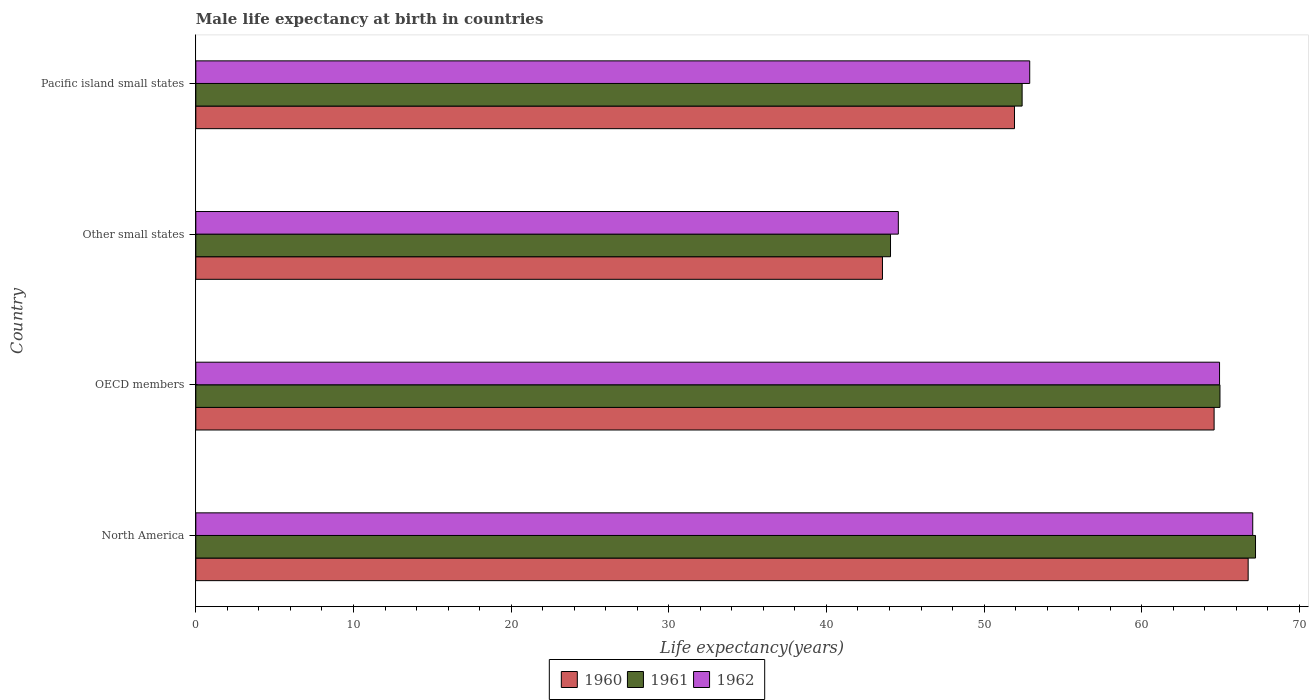How many different coloured bars are there?
Your answer should be compact. 3. How many groups of bars are there?
Your answer should be compact. 4. How many bars are there on the 3rd tick from the bottom?
Your answer should be compact. 3. What is the label of the 2nd group of bars from the top?
Ensure brevity in your answer.  Other small states. In how many cases, is the number of bars for a given country not equal to the number of legend labels?
Offer a very short reply. 0. What is the male life expectancy at birth in 1962 in Other small states?
Provide a succinct answer. 44.56. Across all countries, what is the maximum male life expectancy at birth in 1962?
Offer a terse response. 67.04. Across all countries, what is the minimum male life expectancy at birth in 1962?
Provide a short and direct response. 44.56. In which country was the male life expectancy at birth in 1960 maximum?
Give a very brief answer. North America. In which country was the male life expectancy at birth in 1960 minimum?
Provide a short and direct response. Other small states. What is the total male life expectancy at birth in 1960 in the graph?
Offer a terse response. 226.83. What is the difference between the male life expectancy at birth in 1960 in OECD members and that in Other small states?
Give a very brief answer. 21.04. What is the difference between the male life expectancy at birth in 1960 in North America and the male life expectancy at birth in 1962 in Other small states?
Give a very brief answer. 22.19. What is the average male life expectancy at birth in 1961 per country?
Provide a succinct answer. 57.17. What is the difference between the male life expectancy at birth in 1960 and male life expectancy at birth in 1962 in OECD members?
Offer a terse response. -0.34. In how many countries, is the male life expectancy at birth in 1960 greater than 46 years?
Make the answer very short. 3. What is the ratio of the male life expectancy at birth in 1961 in Other small states to that in Pacific island small states?
Provide a short and direct response. 0.84. Is the male life expectancy at birth in 1962 in North America less than that in Pacific island small states?
Provide a succinct answer. No. Is the difference between the male life expectancy at birth in 1960 in North America and Other small states greater than the difference between the male life expectancy at birth in 1962 in North America and Other small states?
Your answer should be very brief. Yes. What is the difference between the highest and the second highest male life expectancy at birth in 1961?
Keep it short and to the point. 2.25. What is the difference between the highest and the lowest male life expectancy at birth in 1962?
Ensure brevity in your answer.  22.48. Is the sum of the male life expectancy at birth in 1961 in OECD members and Other small states greater than the maximum male life expectancy at birth in 1962 across all countries?
Give a very brief answer. Yes. What does the 3rd bar from the bottom in Other small states represents?
Keep it short and to the point. 1962. How many countries are there in the graph?
Keep it short and to the point. 4. What is the difference between two consecutive major ticks on the X-axis?
Provide a short and direct response. 10. How many legend labels are there?
Ensure brevity in your answer.  3. How are the legend labels stacked?
Your answer should be very brief. Horizontal. What is the title of the graph?
Keep it short and to the point. Male life expectancy at birth in countries. What is the label or title of the X-axis?
Make the answer very short. Life expectancy(years). What is the Life expectancy(years) in 1960 in North America?
Your answer should be very brief. 66.75. What is the Life expectancy(years) in 1961 in North America?
Your answer should be very brief. 67.22. What is the Life expectancy(years) in 1962 in North America?
Provide a short and direct response. 67.04. What is the Life expectancy(years) of 1960 in OECD members?
Offer a very short reply. 64.59. What is the Life expectancy(years) of 1961 in OECD members?
Offer a very short reply. 64.96. What is the Life expectancy(years) in 1962 in OECD members?
Provide a short and direct response. 64.94. What is the Life expectancy(years) in 1960 in Other small states?
Your answer should be compact. 43.56. What is the Life expectancy(years) in 1961 in Other small states?
Offer a very short reply. 44.07. What is the Life expectancy(years) in 1962 in Other small states?
Your answer should be compact. 44.56. What is the Life expectancy(years) in 1960 in Pacific island small states?
Make the answer very short. 51.93. What is the Life expectancy(years) of 1961 in Pacific island small states?
Make the answer very short. 52.41. What is the Life expectancy(years) in 1962 in Pacific island small states?
Offer a very short reply. 52.9. Across all countries, what is the maximum Life expectancy(years) in 1960?
Offer a very short reply. 66.75. Across all countries, what is the maximum Life expectancy(years) of 1961?
Provide a succinct answer. 67.22. Across all countries, what is the maximum Life expectancy(years) of 1962?
Make the answer very short. 67.04. Across all countries, what is the minimum Life expectancy(years) in 1960?
Offer a terse response. 43.56. Across all countries, what is the minimum Life expectancy(years) in 1961?
Your response must be concise. 44.07. Across all countries, what is the minimum Life expectancy(years) in 1962?
Make the answer very short. 44.56. What is the total Life expectancy(years) in 1960 in the graph?
Keep it short and to the point. 226.83. What is the total Life expectancy(years) of 1961 in the graph?
Provide a succinct answer. 228.66. What is the total Life expectancy(years) in 1962 in the graph?
Give a very brief answer. 229.44. What is the difference between the Life expectancy(years) in 1960 in North America and that in OECD members?
Make the answer very short. 2.16. What is the difference between the Life expectancy(years) in 1961 in North America and that in OECD members?
Offer a very short reply. 2.25. What is the difference between the Life expectancy(years) of 1962 in North America and that in OECD members?
Give a very brief answer. 2.11. What is the difference between the Life expectancy(years) of 1960 in North America and that in Other small states?
Your response must be concise. 23.2. What is the difference between the Life expectancy(years) in 1961 in North America and that in Other small states?
Your answer should be compact. 23.15. What is the difference between the Life expectancy(years) in 1962 in North America and that in Other small states?
Your answer should be compact. 22.48. What is the difference between the Life expectancy(years) in 1960 in North America and that in Pacific island small states?
Provide a short and direct response. 14.82. What is the difference between the Life expectancy(years) of 1961 in North America and that in Pacific island small states?
Make the answer very short. 14.8. What is the difference between the Life expectancy(years) in 1962 in North America and that in Pacific island small states?
Offer a terse response. 14.15. What is the difference between the Life expectancy(years) in 1960 in OECD members and that in Other small states?
Offer a terse response. 21.04. What is the difference between the Life expectancy(years) of 1961 in OECD members and that in Other small states?
Offer a terse response. 20.9. What is the difference between the Life expectancy(years) of 1962 in OECD members and that in Other small states?
Ensure brevity in your answer.  20.38. What is the difference between the Life expectancy(years) in 1960 in OECD members and that in Pacific island small states?
Make the answer very short. 12.66. What is the difference between the Life expectancy(years) of 1961 in OECD members and that in Pacific island small states?
Make the answer very short. 12.55. What is the difference between the Life expectancy(years) of 1962 in OECD members and that in Pacific island small states?
Offer a very short reply. 12.04. What is the difference between the Life expectancy(years) of 1960 in Other small states and that in Pacific island small states?
Provide a succinct answer. -8.37. What is the difference between the Life expectancy(years) in 1961 in Other small states and that in Pacific island small states?
Provide a succinct answer. -8.35. What is the difference between the Life expectancy(years) in 1962 in Other small states and that in Pacific island small states?
Your answer should be very brief. -8.33. What is the difference between the Life expectancy(years) of 1960 in North America and the Life expectancy(years) of 1961 in OECD members?
Ensure brevity in your answer.  1.79. What is the difference between the Life expectancy(years) of 1960 in North America and the Life expectancy(years) of 1962 in OECD members?
Make the answer very short. 1.82. What is the difference between the Life expectancy(years) of 1961 in North America and the Life expectancy(years) of 1962 in OECD members?
Offer a terse response. 2.28. What is the difference between the Life expectancy(years) of 1960 in North America and the Life expectancy(years) of 1961 in Other small states?
Make the answer very short. 22.69. What is the difference between the Life expectancy(years) in 1960 in North America and the Life expectancy(years) in 1962 in Other small states?
Make the answer very short. 22.19. What is the difference between the Life expectancy(years) in 1961 in North America and the Life expectancy(years) in 1962 in Other small states?
Provide a succinct answer. 22.66. What is the difference between the Life expectancy(years) in 1960 in North America and the Life expectancy(years) in 1961 in Pacific island small states?
Offer a very short reply. 14.34. What is the difference between the Life expectancy(years) of 1960 in North America and the Life expectancy(years) of 1962 in Pacific island small states?
Offer a very short reply. 13.86. What is the difference between the Life expectancy(years) of 1961 in North America and the Life expectancy(years) of 1962 in Pacific island small states?
Your answer should be compact. 14.32. What is the difference between the Life expectancy(years) in 1960 in OECD members and the Life expectancy(years) in 1961 in Other small states?
Your response must be concise. 20.53. What is the difference between the Life expectancy(years) of 1960 in OECD members and the Life expectancy(years) of 1962 in Other small states?
Your answer should be compact. 20.03. What is the difference between the Life expectancy(years) of 1961 in OECD members and the Life expectancy(years) of 1962 in Other small states?
Give a very brief answer. 20.4. What is the difference between the Life expectancy(years) in 1960 in OECD members and the Life expectancy(years) in 1961 in Pacific island small states?
Provide a succinct answer. 12.18. What is the difference between the Life expectancy(years) in 1960 in OECD members and the Life expectancy(years) in 1962 in Pacific island small states?
Keep it short and to the point. 11.7. What is the difference between the Life expectancy(years) of 1961 in OECD members and the Life expectancy(years) of 1962 in Pacific island small states?
Offer a very short reply. 12.07. What is the difference between the Life expectancy(years) in 1960 in Other small states and the Life expectancy(years) in 1961 in Pacific island small states?
Your response must be concise. -8.86. What is the difference between the Life expectancy(years) of 1960 in Other small states and the Life expectancy(years) of 1962 in Pacific island small states?
Your response must be concise. -9.34. What is the difference between the Life expectancy(years) in 1961 in Other small states and the Life expectancy(years) in 1962 in Pacific island small states?
Ensure brevity in your answer.  -8.83. What is the average Life expectancy(years) of 1960 per country?
Make the answer very short. 56.71. What is the average Life expectancy(years) of 1961 per country?
Provide a succinct answer. 57.17. What is the average Life expectancy(years) of 1962 per country?
Keep it short and to the point. 57.36. What is the difference between the Life expectancy(years) in 1960 and Life expectancy(years) in 1961 in North America?
Keep it short and to the point. -0.47. What is the difference between the Life expectancy(years) of 1960 and Life expectancy(years) of 1962 in North America?
Offer a terse response. -0.29. What is the difference between the Life expectancy(years) of 1961 and Life expectancy(years) of 1962 in North America?
Your answer should be very brief. 0.18. What is the difference between the Life expectancy(years) of 1960 and Life expectancy(years) of 1961 in OECD members?
Give a very brief answer. -0.37. What is the difference between the Life expectancy(years) of 1960 and Life expectancy(years) of 1962 in OECD members?
Offer a very short reply. -0.34. What is the difference between the Life expectancy(years) in 1961 and Life expectancy(years) in 1962 in OECD members?
Offer a very short reply. 0.03. What is the difference between the Life expectancy(years) of 1960 and Life expectancy(years) of 1961 in Other small states?
Provide a short and direct response. -0.51. What is the difference between the Life expectancy(years) of 1960 and Life expectancy(years) of 1962 in Other small states?
Offer a terse response. -1.01. What is the difference between the Life expectancy(years) of 1961 and Life expectancy(years) of 1962 in Other small states?
Make the answer very short. -0.5. What is the difference between the Life expectancy(years) in 1960 and Life expectancy(years) in 1961 in Pacific island small states?
Offer a very short reply. -0.49. What is the difference between the Life expectancy(years) in 1960 and Life expectancy(years) in 1962 in Pacific island small states?
Provide a succinct answer. -0.97. What is the difference between the Life expectancy(years) in 1961 and Life expectancy(years) in 1962 in Pacific island small states?
Give a very brief answer. -0.48. What is the ratio of the Life expectancy(years) in 1960 in North America to that in OECD members?
Provide a succinct answer. 1.03. What is the ratio of the Life expectancy(years) of 1961 in North America to that in OECD members?
Your answer should be very brief. 1.03. What is the ratio of the Life expectancy(years) in 1962 in North America to that in OECD members?
Your response must be concise. 1.03. What is the ratio of the Life expectancy(years) of 1960 in North America to that in Other small states?
Provide a short and direct response. 1.53. What is the ratio of the Life expectancy(years) of 1961 in North America to that in Other small states?
Provide a succinct answer. 1.53. What is the ratio of the Life expectancy(years) in 1962 in North America to that in Other small states?
Give a very brief answer. 1.5. What is the ratio of the Life expectancy(years) in 1960 in North America to that in Pacific island small states?
Keep it short and to the point. 1.29. What is the ratio of the Life expectancy(years) in 1961 in North America to that in Pacific island small states?
Make the answer very short. 1.28. What is the ratio of the Life expectancy(years) of 1962 in North America to that in Pacific island small states?
Your response must be concise. 1.27. What is the ratio of the Life expectancy(years) in 1960 in OECD members to that in Other small states?
Ensure brevity in your answer.  1.48. What is the ratio of the Life expectancy(years) of 1961 in OECD members to that in Other small states?
Provide a succinct answer. 1.47. What is the ratio of the Life expectancy(years) in 1962 in OECD members to that in Other small states?
Your response must be concise. 1.46. What is the ratio of the Life expectancy(years) of 1960 in OECD members to that in Pacific island small states?
Your answer should be compact. 1.24. What is the ratio of the Life expectancy(years) in 1961 in OECD members to that in Pacific island small states?
Keep it short and to the point. 1.24. What is the ratio of the Life expectancy(years) of 1962 in OECD members to that in Pacific island small states?
Make the answer very short. 1.23. What is the ratio of the Life expectancy(years) of 1960 in Other small states to that in Pacific island small states?
Ensure brevity in your answer.  0.84. What is the ratio of the Life expectancy(years) of 1961 in Other small states to that in Pacific island small states?
Your answer should be compact. 0.84. What is the ratio of the Life expectancy(years) of 1962 in Other small states to that in Pacific island small states?
Provide a succinct answer. 0.84. What is the difference between the highest and the second highest Life expectancy(years) in 1960?
Provide a succinct answer. 2.16. What is the difference between the highest and the second highest Life expectancy(years) of 1961?
Offer a terse response. 2.25. What is the difference between the highest and the second highest Life expectancy(years) of 1962?
Your answer should be very brief. 2.11. What is the difference between the highest and the lowest Life expectancy(years) in 1960?
Your answer should be compact. 23.2. What is the difference between the highest and the lowest Life expectancy(years) in 1961?
Give a very brief answer. 23.15. What is the difference between the highest and the lowest Life expectancy(years) in 1962?
Give a very brief answer. 22.48. 